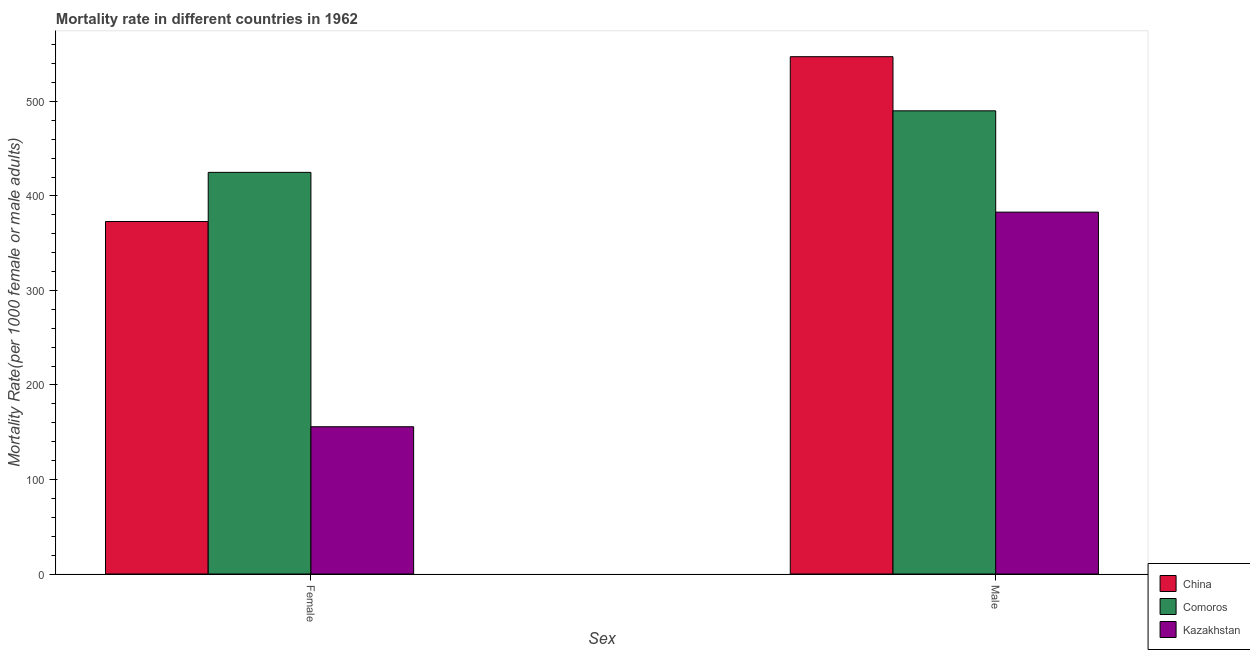How many different coloured bars are there?
Your answer should be very brief. 3. How many groups of bars are there?
Provide a succinct answer. 2. Are the number of bars on each tick of the X-axis equal?
Make the answer very short. Yes. How many bars are there on the 2nd tick from the left?
Your answer should be very brief. 3. How many bars are there on the 1st tick from the right?
Offer a terse response. 3. What is the female mortality rate in Comoros?
Your answer should be compact. 424.98. Across all countries, what is the maximum male mortality rate?
Your answer should be very brief. 547.37. Across all countries, what is the minimum male mortality rate?
Ensure brevity in your answer.  382.9. In which country was the female mortality rate maximum?
Ensure brevity in your answer.  Comoros. In which country was the female mortality rate minimum?
Offer a terse response. Kazakhstan. What is the total female mortality rate in the graph?
Provide a short and direct response. 953.76. What is the difference between the female mortality rate in Comoros and that in Kazakhstan?
Your answer should be compact. 269.16. What is the difference between the male mortality rate in Comoros and the female mortality rate in China?
Keep it short and to the point. 117.14. What is the average female mortality rate per country?
Offer a very short reply. 317.92. What is the difference between the female mortality rate and male mortality rate in Comoros?
Give a very brief answer. -65.12. In how many countries, is the male mortality rate greater than 40 ?
Provide a succinct answer. 3. What is the ratio of the male mortality rate in Comoros to that in Kazakhstan?
Your answer should be very brief. 1.28. In how many countries, is the female mortality rate greater than the average female mortality rate taken over all countries?
Keep it short and to the point. 2. What does the 1st bar from the left in Male represents?
Your answer should be compact. China. What does the 1st bar from the right in Male represents?
Ensure brevity in your answer.  Kazakhstan. How many bars are there?
Offer a very short reply. 6. How many legend labels are there?
Provide a short and direct response. 3. What is the title of the graph?
Keep it short and to the point. Mortality rate in different countries in 1962. Does "Saudi Arabia" appear as one of the legend labels in the graph?
Offer a terse response. No. What is the label or title of the X-axis?
Make the answer very short. Sex. What is the label or title of the Y-axis?
Make the answer very short. Mortality Rate(per 1000 female or male adults). What is the Mortality Rate(per 1000 female or male adults) in China in Female?
Provide a short and direct response. 372.96. What is the Mortality Rate(per 1000 female or male adults) of Comoros in Female?
Provide a short and direct response. 424.98. What is the Mortality Rate(per 1000 female or male adults) in Kazakhstan in Female?
Offer a very short reply. 155.82. What is the Mortality Rate(per 1000 female or male adults) of China in Male?
Keep it short and to the point. 547.37. What is the Mortality Rate(per 1000 female or male adults) of Comoros in Male?
Offer a very short reply. 490.1. What is the Mortality Rate(per 1000 female or male adults) of Kazakhstan in Male?
Give a very brief answer. 382.9. Across all Sex, what is the maximum Mortality Rate(per 1000 female or male adults) in China?
Keep it short and to the point. 547.37. Across all Sex, what is the maximum Mortality Rate(per 1000 female or male adults) of Comoros?
Offer a very short reply. 490.1. Across all Sex, what is the maximum Mortality Rate(per 1000 female or male adults) in Kazakhstan?
Provide a short and direct response. 382.9. Across all Sex, what is the minimum Mortality Rate(per 1000 female or male adults) of China?
Your answer should be very brief. 372.96. Across all Sex, what is the minimum Mortality Rate(per 1000 female or male adults) in Comoros?
Provide a succinct answer. 424.98. Across all Sex, what is the minimum Mortality Rate(per 1000 female or male adults) of Kazakhstan?
Your response must be concise. 155.82. What is the total Mortality Rate(per 1000 female or male adults) in China in the graph?
Make the answer very short. 920.33. What is the total Mortality Rate(per 1000 female or male adults) of Comoros in the graph?
Ensure brevity in your answer.  915.08. What is the total Mortality Rate(per 1000 female or male adults) in Kazakhstan in the graph?
Provide a short and direct response. 538.72. What is the difference between the Mortality Rate(per 1000 female or male adults) in China in Female and that in Male?
Ensure brevity in your answer.  -174.41. What is the difference between the Mortality Rate(per 1000 female or male adults) in Comoros in Female and that in Male?
Your answer should be very brief. -65.12. What is the difference between the Mortality Rate(per 1000 female or male adults) of Kazakhstan in Female and that in Male?
Your response must be concise. -227.08. What is the difference between the Mortality Rate(per 1000 female or male adults) of China in Female and the Mortality Rate(per 1000 female or male adults) of Comoros in Male?
Keep it short and to the point. -117.14. What is the difference between the Mortality Rate(per 1000 female or male adults) in China in Female and the Mortality Rate(per 1000 female or male adults) in Kazakhstan in Male?
Your answer should be very brief. -9.94. What is the difference between the Mortality Rate(per 1000 female or male adults) of Comoros in Female and the Mortality Rate(per 1000 female or male adults) of Kazakhstan in Male?
Ensure brevity in your answer.  42.08. What is the average Mortality Rate(per 1000 female or male adults) in China per Sex?
Provide a succinct answer. 460.17. What is the average Mortality Rate(per 1000 female or male adults) of Comoros per Sex?
Offer a very short reply. 457.54. What is the average Mortality Rate(per 1000 female or male adults) in Kazakhstan per Sex?
Provide a short and direct response. 269.36. What is the difference between the Mortality Rate(per 1000 female or male adults) of China and Mortality Rate(per 1000 female or male adults) of Comoros in Female?
Give a very brief answer. -52.02. What is the difference between the Mortality Rate(per 1000 female or male adults) in China and Mortality Rate(per 1000 female or male adults) in Kazakhstan in Female?
Keep it short and to the point. 217.14. What is the difference between the Mortality Rate(per 1000 female or male adults) of Comoros and Mortality Rate(per 1000 female or male adults) of Kazakhstan in Female?
Provide a short and direct response. 269.16. What is the difference between the Mortality Rate(per 1000 female or male adults) of China and Mortality Rate(per 1000 female or male adults) of Comoros in Male?
Your answer should be very brief. 57.27. What is the difference between the Mortality Rate(per 1000 female or male adults) in China and Mortality Rate(per 1000 female or male adults) in Kazakhstan in Male?
Your answer should be compact. 164.47. What is the difference between the Mortality Rate(per 1000 female or male adults) in Comoros and Mortality Rate(per 1000 female or male adults) in Kazakhstan in Male?
Provide a succinct answer. 107.2. What is the ratio of the Mortality Rate(per 1000 female or male adults) of China in Female to that in Male?
Keep it short and to the point. 0.68. What is the ratio of the Mortality Rate(per 1000 female or male adults) of Comoros in Female to that in Male?
Keep it short and to the point. 0.87. What is the ratio of the Mortality Rate(per 1000 female or male adults) in Kazakhstan in Female to that in Male?
Your response must be concise. 0.41. What is the difference between the highest and the second highest Mortality Rate(per 1000 female or male adults) in China?
Your response must be concise. 174.41. What is the difference between the highest and the second highest Mortality Rate(per 1000 female or male adults) in Comoros?
Your answer should be compact. 65.12. What is the difference between the highest and the second highest Mortality Rate(per 1000 female or male adults) in Kazakhstan?
Offer a terse response. 227.08. What is the difference between the highest and the lowest Mortality Rate(per 1000 female or male adults) in China?
Offer a terse response. 174.41. What is the difference between the highest and the lowest Mortality Rate(per 1000 female or male adults) of Comoros?
Provide a succinct answer. 65.12. What is the difference between the highest and the lowest Mortality Rate(per 1000 female or male adults) of Kazakhstan?
Ensure brevity in your answer.  227.08. 